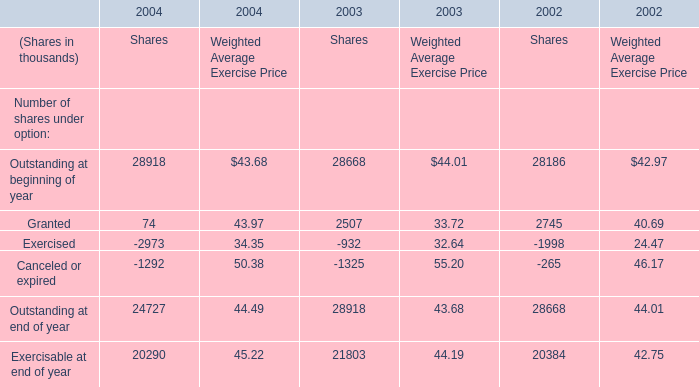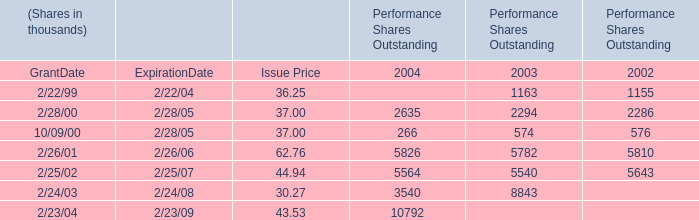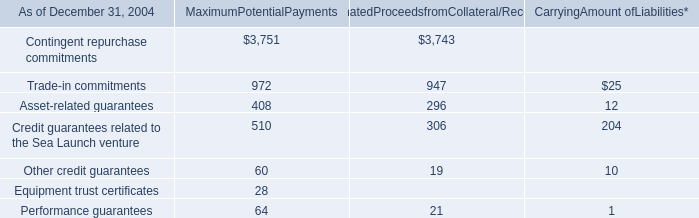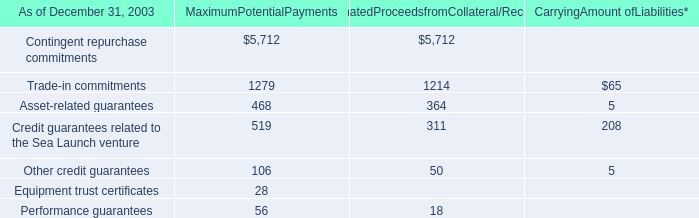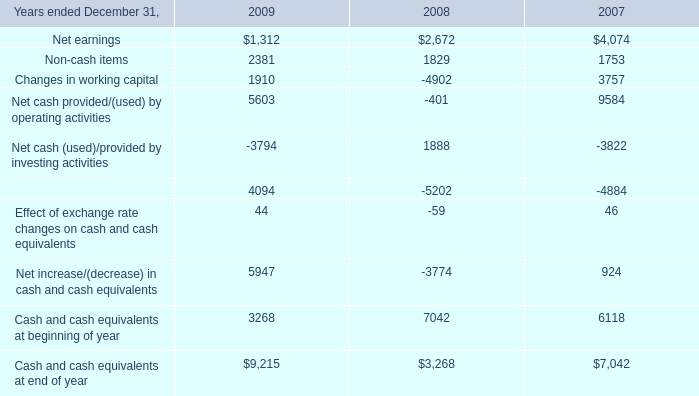What is the sum of Cash and cash equivalents at beginning of year of 2007, 2/22/99 of Performance Shares Outstanding 2003, and Outstanding at beginning of year of 2003 Shares ? 
Computations: ((6118.0 + 1163.0) + 28668.0)
Answer: 35949.0. 